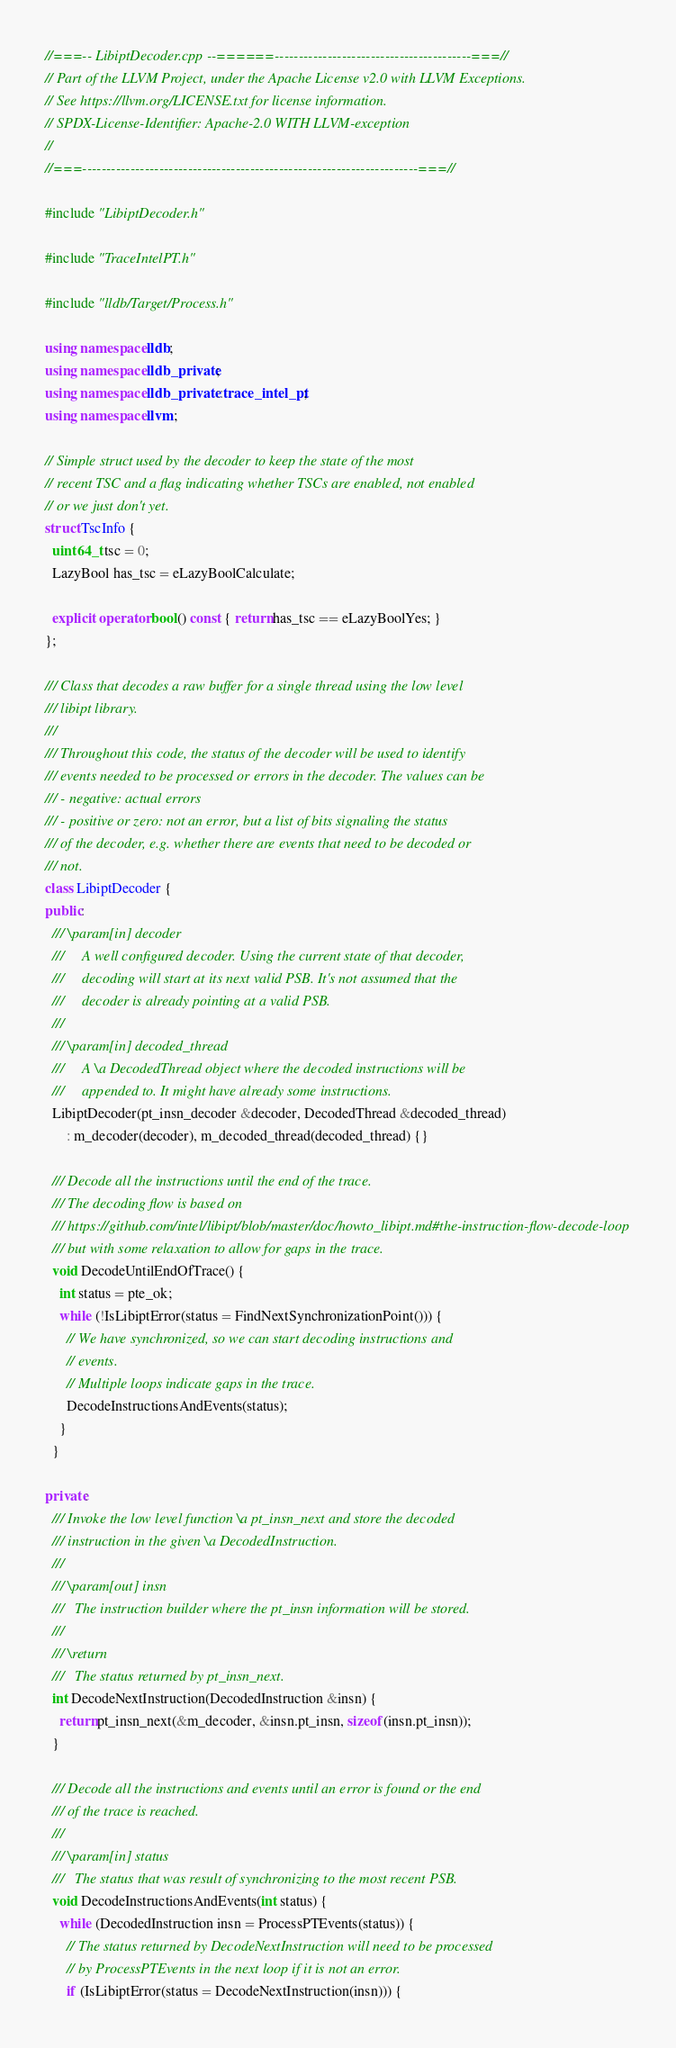<code> <loc_0><loc_0><loc_500><loc_500><_C++_>//===-- LibiptDecoder.cpp --======-----------------------------------------===//
// Part of the LLVM Project, under the Apache License v2.0 with LLVM Exceptions.
// See https://llvm.org/LICENSE.txt for license information.
// SPDX-License-Identifier: Apache-2.0 WITH LLVM-exception
//
//===----------------------------------------------------------------------===//

#include "LibiptDecoder.h"

#include "TraceIntelPT.h"

#include "lldb/Target/Process.h"

using namespace lldb;
using namespace lldb_private;
using namespace lldb_private::trace_intel_pt;
using namespace llvm;

// Simple struct used by the decoder to keep the state of the most
// recent TSC and a flag indicating whether TSCs are enabled, not enabled
// or we just don't yet.
struct TscInfo {
  uint64_t tsc = 0;
  LazyBool has_tsc = eLazyBoolCalculate;

  explicit operator bool() const { return has_tsc == eLazyBoolYes; }
};

/// Class that decodes a raw buffer for a single thread using the low level
/// libipt library.
///
/// Throughout this code, the status of the decoder will be used to identify
/// events needed to be processed or errors in the decoder. The values can be
/// - negative: actual errors
/// - positive or zero: not an error, but a list of bits signaling the status
/// of the decoder, e.g. whether there are events that need to be decoded or
/// not.
class LibiptDecoder {
public:
  /// \param[in] decoder
  ///     A well configured decoder. Using the current state of that decoder,
  ///     decoding will start at its next valid PSB. It's not assumed that the
  ///     decoder is already pointing at a valid PSB.
  ///
  /// \param[in] decoded_thread
  ///     A \a DecodedThread object where the decoded instructions will be
  ///     appended to. It might have already some instructions.
  LibiptDecoder(pt_insn_decoder &decoder, DecodedThread &decoded_thread)
      : m_decoder(decoder), m_decoded_thread(decoded_thread) {}

  /// Decode all the instructions until the end of the trace.
  /// The decoding flow is based on
  /// https://github.com/intel/libipt/blob/master/doc/howto_libipt.md#the-instruction-flow-decode-loop
  /// but with some relaxation to allow for gaps in the trace.
  void DecodeUntilEndOfTrace() {
    int status = pte_ok;
    while (!IsLibiptError(status = FindNextSynchronizationPoint())) {
      // We have synchronized, so we can start decoding instructions and
      // events.
      // Multiple loops indicate gaps in the trace.
      DecodeInstructionsAndEvents(status);
    }
  }

private:
  /// Invoke the low level function \a pt_insn_next and store the decoded
  /// instruction in the given \a DecodedInstruction.
  ///
  /// \param[out] insn
  ///   The instruction builder where the pt_insn information will be stored.
  ///
  /// \return
  ///   The status returned by pt_insn_next.
  int DecodeNextInstruction(DecodedInstruction &insn) {
    return pt_insn_next(&m_decoder, &insn.pt_insn, sizeof(insn.pt_insn));
  }

  /// Decode all the instructions and events until an error is found or the end
  /// of the trace is reached.
  ///
  /// \param[in] status
  ///   The status that was result of synchronizing to the most recent PSB.
  void DecodeInstructionsAndEvents(int status) {
    while (DecodedInstruction insn = ProcessPTEvents(status)) {
      // The status returned by DecodeNextInstruction will need to be processed
      // by ProcessPTEvents in the next loop if it is not an error.
      if (IsLibiptError(status = DecodeNextInstruction(insn))) {</code> 